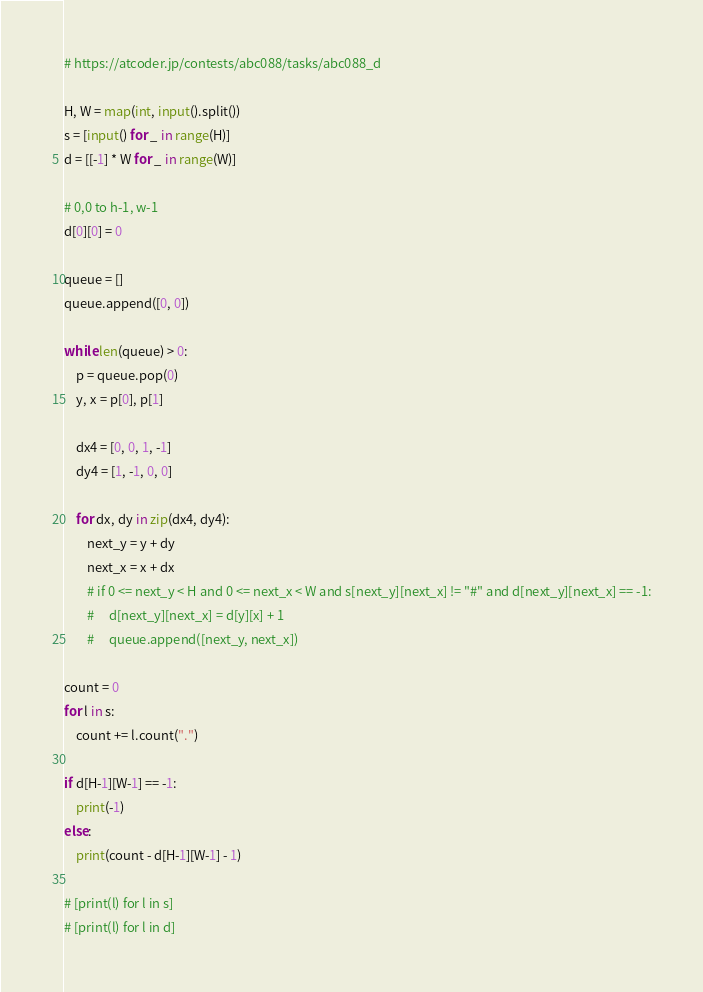<code> <loc_0><loc_0><loc_500><loc_500><_Python_># https://atcoder.jp/contests/abc088/tasks/abc088_d

H, W = map(int, input().split())
s = [input() for _ in range(H)]
d = [[-1] * W for _ in range(W)]

# 0,0 to h-1, w-1
d[0][0] = 0

queue = []
queue.append([0, 0])

while len(queue) > 0:
    p = queue.pop(0)
    y, x = p[0], p[1]

    dx4 = [0, 0, 1, -1]
    dy4 = [1, -1, 0, 0]

    for dx, dy in zip(dx4, dy4):
        next_y = y + dy
        next_x = x + dx
        # if 0 <= next_y < H and 0 <= next_x < W and s[next_y][next_x] != "#" and d[next_y][next_x] == -1:
        #     d[next_y][next_x] = d[y][x] + 1
        #     queue.append([next_y, next_x])

count = 0
for l in s:
    count += l.count(".")

if d[H-1][W-1] == -1:
    print(-1)
else:
    print(count - d[H-1][W-1] - 1)

# [print(l) for l in s]
# [print(l) for l in d]
</code> 